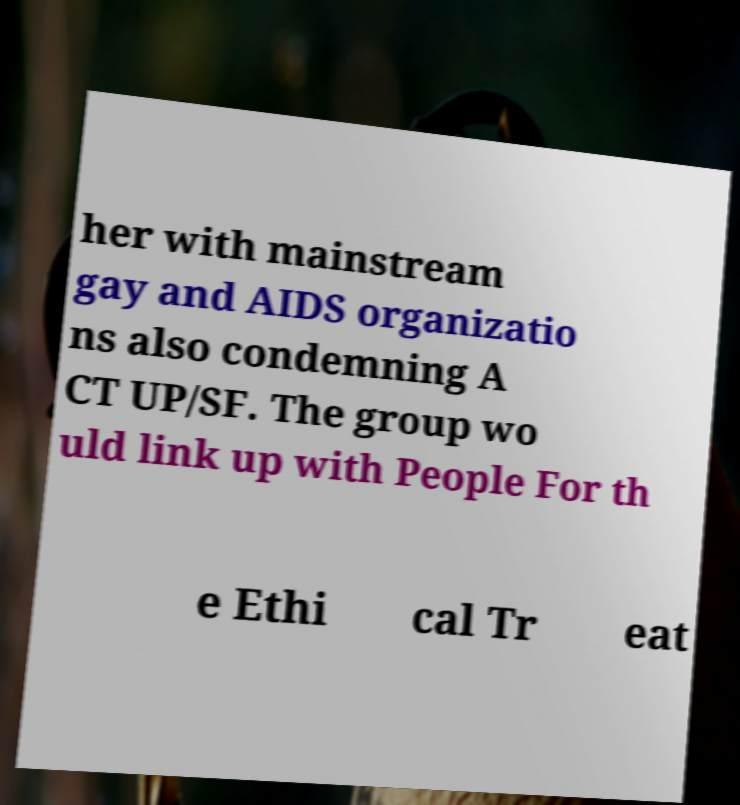I need the written content from this picture converted into text. Can you do that? her with mainstream gay and AIDS organizatio ns also condemning A CT UP/SF. The group wo uld link up with People For th e Ethi cal Tr eat 